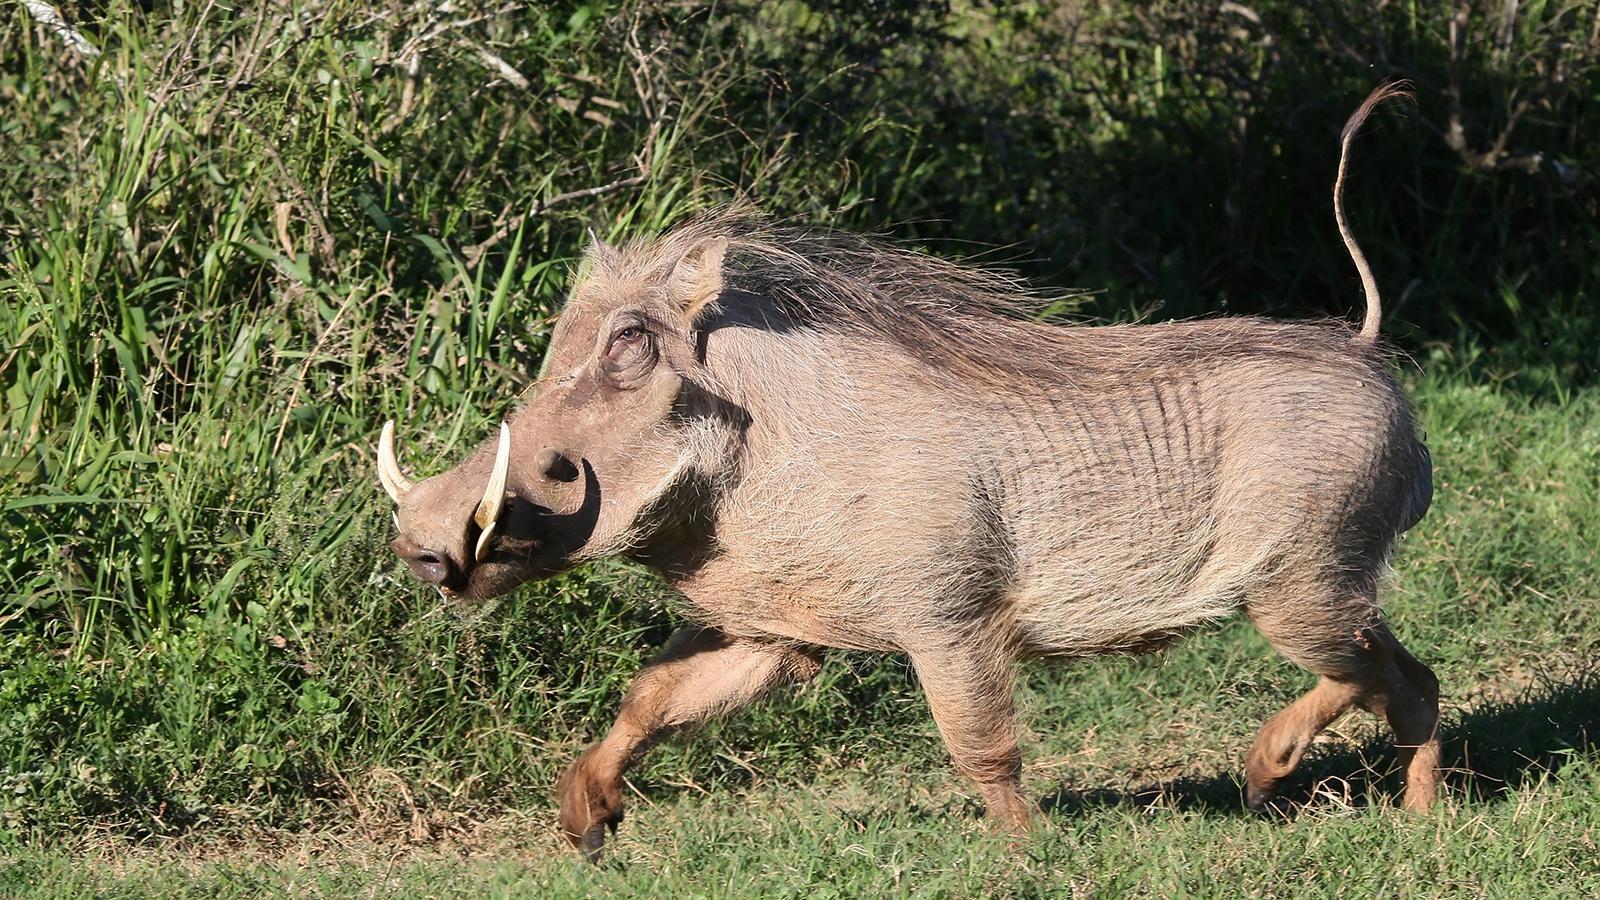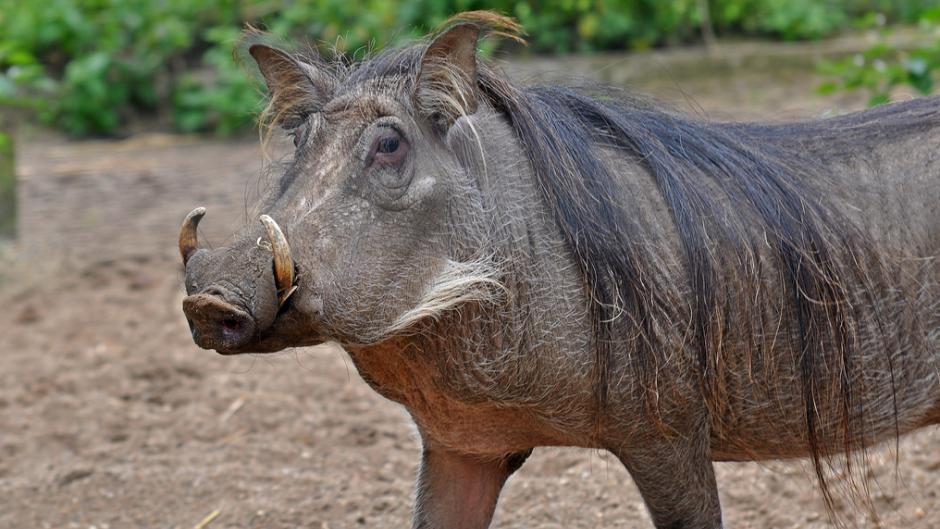The first image is the image on the left, the second image is the image on the right. Examine the images to the left and right. Is the description "An image contains both juvenile and adult warthogs, and features small animals standing by a taller animal." accurate? Answer yes or no. No. The first image is the image on the left, the second image is the image on the right. Examine the images to the left and right. Is the description "There are more than one animals in on of the images." accurate? Answer yes or no. No. 